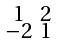Convert formula to latex. <formula><loc_0><loc_0><loc_500><loc_500>\begin{smallmatrix} 1 & 2 \\ - 2 & 1 \end{smallmatrix}</formula> 